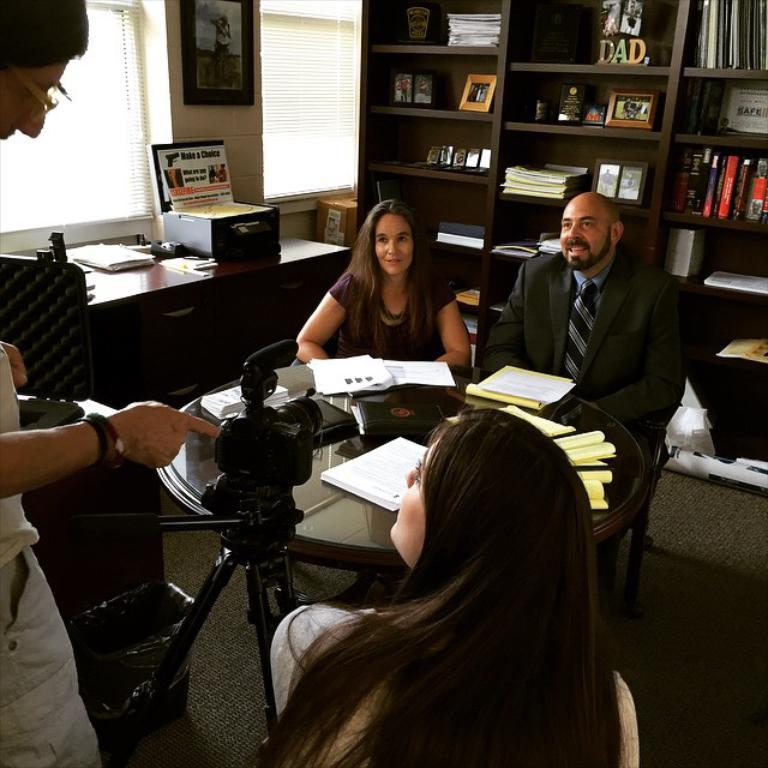<image>
Write a terse but informative summary of the picture. Some people around a small table being filed with a Make a Choice board to the side. 